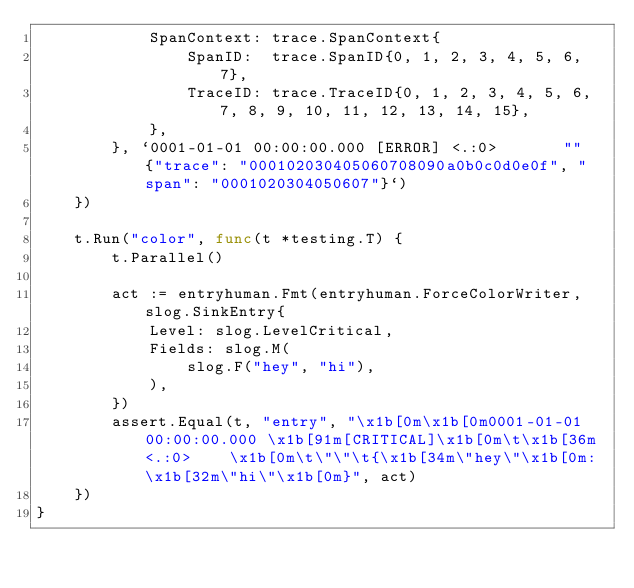<code> <loc_0><loc_0><loc_500><loc_500><_Go_>			SpanContext: trace.SpanContext{
				SpanID:  trace.SpanID{0, 1, 2, 3, 4, 5, 6, 7},
				TraceID: trace.TraceID{0, 1, 2, 3, 4, 5, 6, 7, 8, 9, 10, 11, 12, 13, 14, 15},
			},
		}, `0001-01-01 00:00:00.000 [ERROR]	<.:0>		""	{"trace": "000102030405060708090a0b0c0d0e0f", "span": "0001020304050607"}`)
	})

	t.Run("color", func(t *testing.T) {
		t.Parallel()

		act := entryhuman.Fmt(entryhuman.ForceColorWriter, slog.SinkEntry{
			Level: slog.LevelCritical,
			Fields: slog.M(
				slog.F("hey", "hi"),
			),
		})
		assert.Equal(t, "entry", "\x1b[0m\x1b[0m0001-01-01 00:00:00.000 \x1b[91m[CRITICAL]\x1b[0m\t\x1b[36m<.:0>	\x1b[0m\t\"\"\t{\x1b[34m\"hey\"\x1b[0m: \x1b[32m\"hi\"\x1b[0m}", act)
	})
}
</code> 